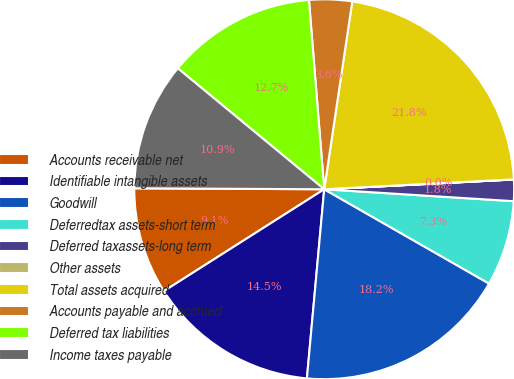Convert chart to OTSL. <chart><loc_0><loc_0><loc_500><loc_500><pie_chart><fcel>Accounts receivable net<fcel>Identifiable intangible assets<fcel>Goodwill<fcel>Deferredtax assets-short term<fcel>Deferred taxassets-long term<fcel>Other assets<fcel>Total assets acquired<fcel>Accounts payable and accrued<fcel>Deferred tax liabilities<fcel>Income taxes payable<nl><fcel>9.09%<fcel>14.54%<fcel>18.18%<fcel>7.27%<fcel>1.82%<fcel>0.01%<fcel>21.81%<fcel>3.64%<fcel>12.73%<fcel>10.91%<nl></chart> 